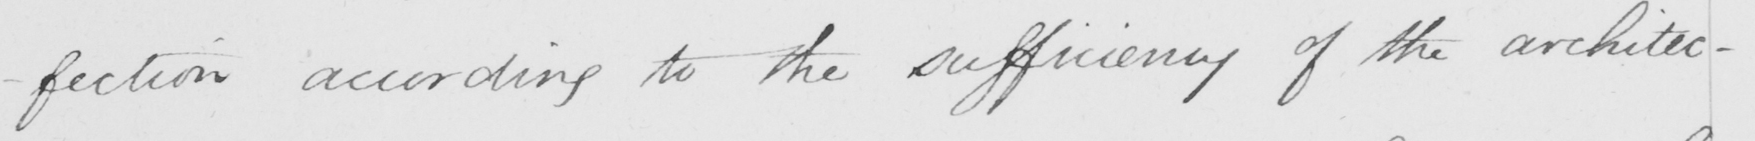What does this handwritten line say? -fection according to the sufficiency of the architec- 